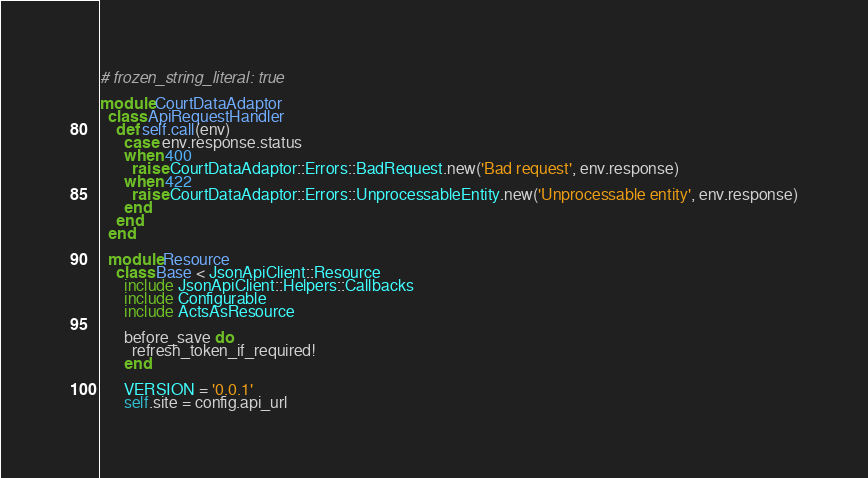<code> <loc_0><loc_0><loc_500><loc_500><_Ruby_># frozen_string_literal: true

module CourtDataAdaptor
  class ApiRequestHandler
    def self.call(env)
      case env.response.status
      when 400
        raise CourtDataAdaptor::Errors::BadRequest.new('Bad request', env.response)
      when 422
        raise CourtDataAdaptor::Errors::UnprocessableEntity.new('Unprocessable entity', env.response)
      end
    end
  end

  module Resource
    class Base < JsonApiClient::Resource
      include JsonApiClient::Helpers::Callbacks
      include Configurable
      include ActsAsResource

      before_save do
        refresh_token_if_required!
      end

      VERSION = '0.0.1'
      self.site = config.api_url
</code> 